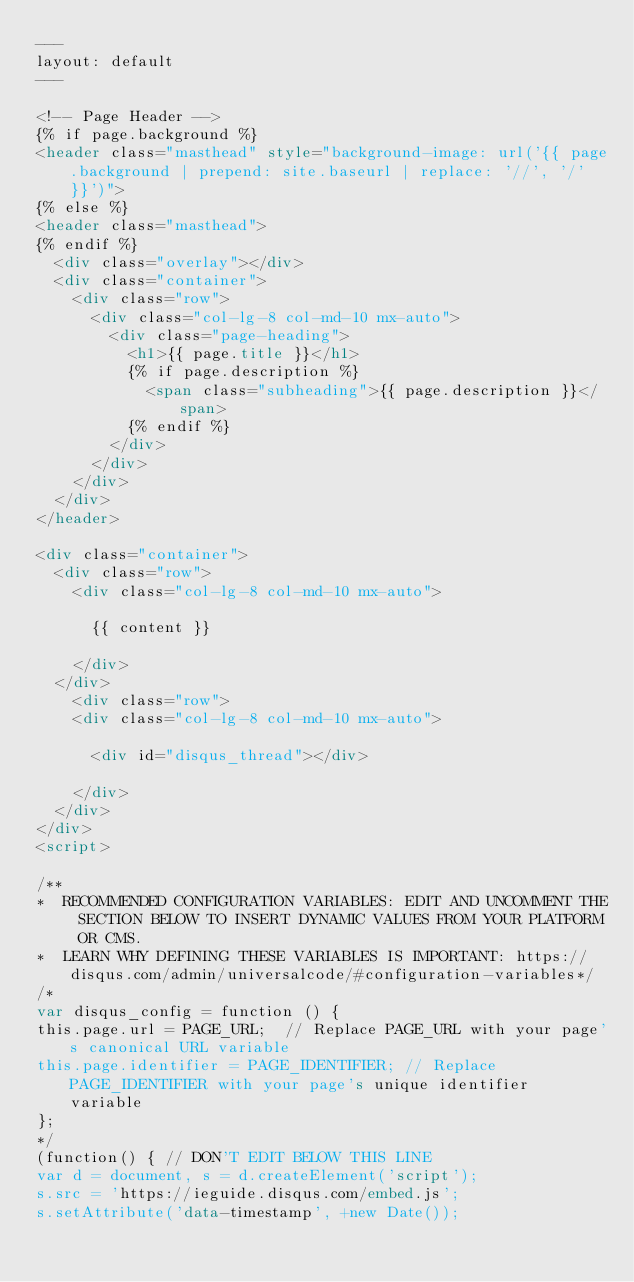<code> <loc_0><loc_0><loc_500><loc_500><_HTML_>---
layout: default
---

<!-- Page Header -->
{% if page.background %}
<header class="masthead" style="background-image: url('{{ page.background | prepend: site.baseurl | replace: '//', '/' }}')">
{% else %}
<header class="masthead">
{% endif %}
  <div class="overlay"></div>
  <div class="container">
    <div class="row">
      <div class="col-lg-8 col-md-10 mx-auto">
        <div class="page-heading">
          <h1>{{ page.title }}</h1>
          {% if page.description %}
            <span class="subheading">{{ page.description }}</span>
          {% endif %}
        </div>
      </div>
    </div>
  </div>
</header>

<div class="container">
  <div class="row">
    <div class="col-lg-8 col-md-10 mx-auto">

      {{ content }}

    </div>
  </div>
    <div class="row">
    <div class="col-lg-8 col-md-10 mx-auto">

      <div id="disqus_thread"></div>

    </div>
  </div>
</div>
<script>

/**
*  RECOMMENDED CONFIGURATION VARIABLES: EDIT AND UNCOMMENT THE SECTION BELOW TO INSERT DYNAMIC VALUES FROM YOUR PLATFORM OR CMS.
*  LEARN WHY DEFINING THESE VARIABLES IS IMPORTANT: https://disqus.com/admin/universalcode/#configuration-variables*/
/*
var disqus_config = function () {
this.page.url = PAGE_URL;  // Replace PAGE_URL with your page's canonical URL variable
this.page.identifier = PAGE_IDENTIFIER; // Replace PAGE_IDENTIFIER with your page's unique identifier variable
};
*/
(function() { // DON'T EDIT BELOW THIS LINE
var d = document, s = d.createElement('script');
s.src = 'https://ieguide.disqus.com/embed.js';
s.setAttribute('data-timestamp', +new Date());</code> 